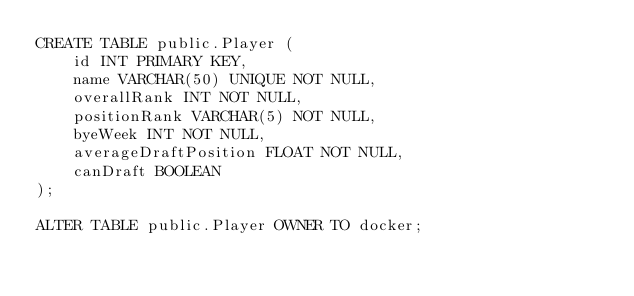Convert code to text. <code><loc_0><loc_0><loc_500><loc_500><_SQL_>CREATE TABLE public.Player (
    id INT PRIMARY KEY,
    name VARCHAR(50) UNIQUE NOT NULL,
    overallRank INT NOT NULL,
    positionRank VARCHAR(5) NOT NULL,
    byeWeek INT NOT NULL,
    averageDraftPosition FLOAT NOT NULL,
    canDraft BOOLEAN
);

ALTER TABLE public.Player OWNER TO docker;
</code> 